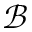<formula> <loc_0><loc_0><loc_500><loc_500>\mathcal { B }</formula> 